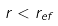<formula> <loc_0><loc_0><loc_500><loc_500>r < r _ { e f }</formula> 